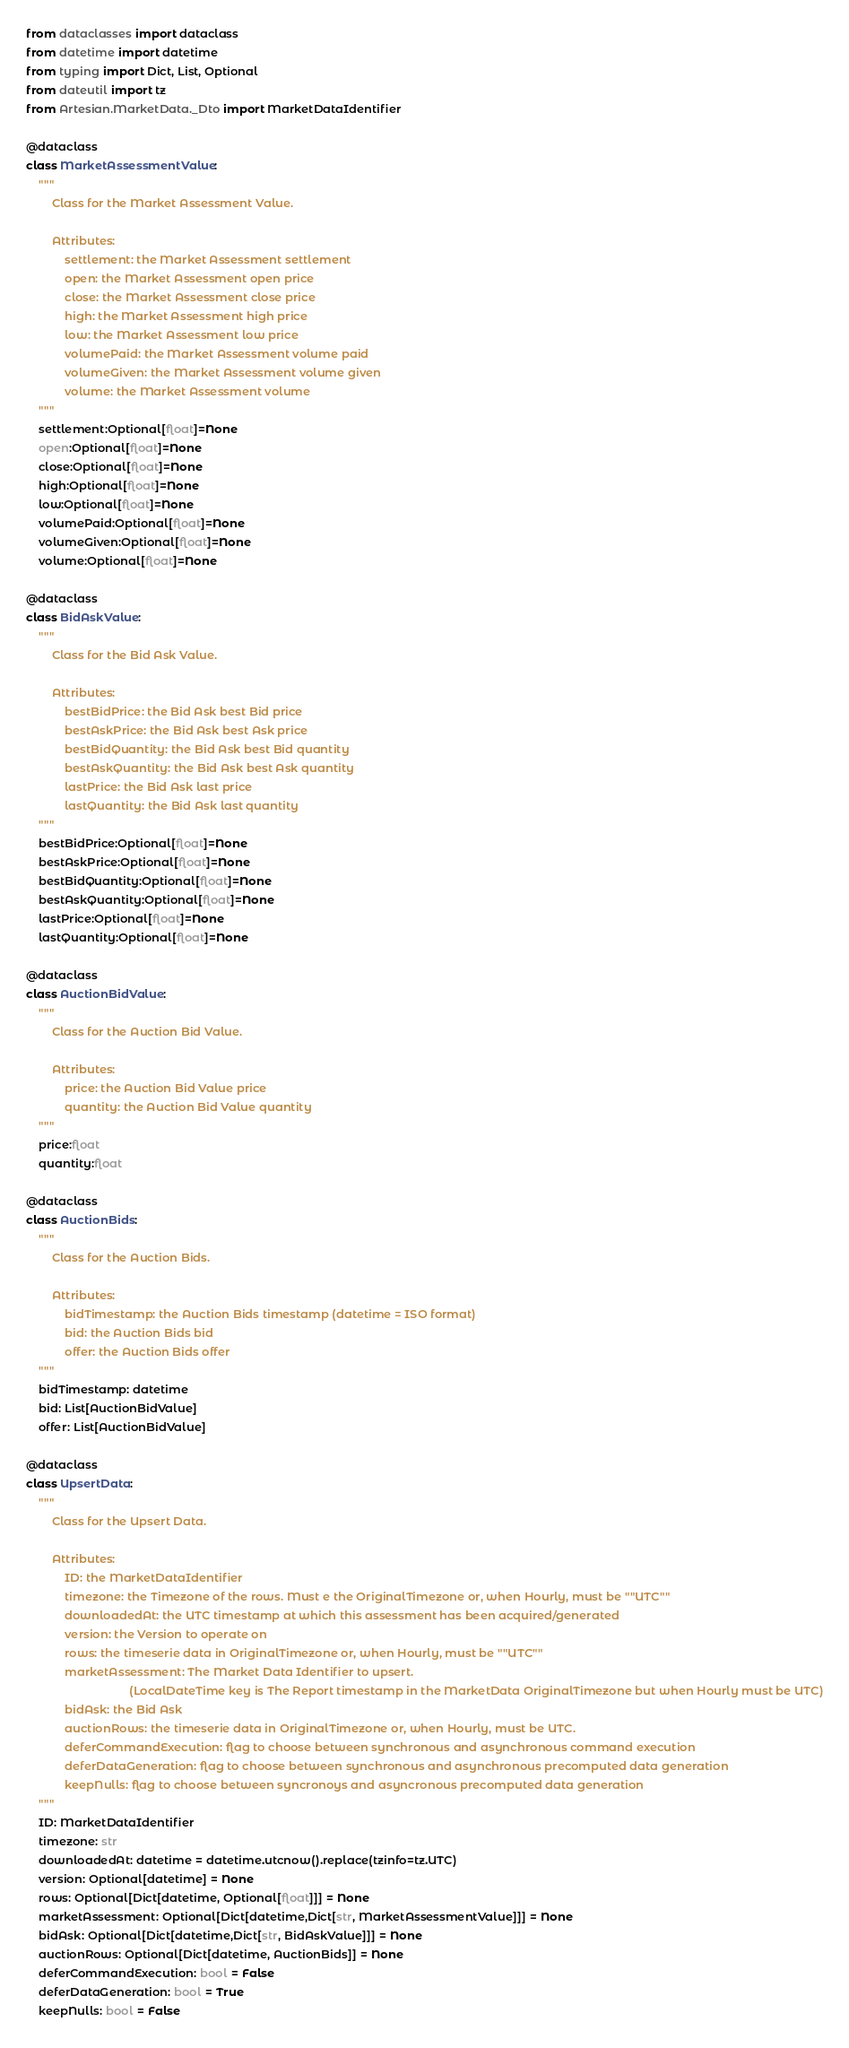<code> <loc_0><loc_0><loc_500><loc_500><_Python_>from dataclasses import dataclass
from datetime import datetime
from typing import Dict, List, Optional
from dateutil import tz
from Artesian.MarketData._Dto import MarketDataIdentifier

@dataclass
class MarketAssessmentValue:
    """
        Class for the Market Assessment Value.

        Attributes:
            settlement: the Market Assessment settlement
            open: the Market Assessment open price
            close: the Market Assessment close price
            high: the Market Assessment high price
            low: the Market Assessment low price
            volumePaid: the Market Assessment volume paid
            volumeGiven: the Market Assessment volume given
            volume: the Market Assessment volume
    """
    settlement:Optional[float]=None
    open:Optional[float]=None
    close:Optional[float]=None
    high:Optional[float]=None
    low:Optional[float]=None
    volumePaid:Optional[float]=None
    volumeGiven:Optional[float]=None
    volume:Optional[float]=None

@dataclass
class BidAskValue:
    """
        Class for the Bid Ask Value.

        Attributes:
            bestBidPrice: the Bid Ask best Bid price
            bestAskPrice: the Bid Ask best Ask price
            bestBidQuantity: the Bid Ask best Bid quantity
            bestAskQuantity: the Bid Ask best Ask quantity
            lastPrice: the Bid Ask last price
            lastQuantity: the Bid Ask last quantity
    """
    bestBidPrice:Optional[float]=None
    bestAskPrice:Optional[float]=None
    bestBidQuantity:Optional[float]=None
    bestAskQuantity:Optional[float]=None
    lastPrice:Optional[float]=None
    lastQuantity:Optional[float]=None

@dataclass
class AuctionBidValue:
    """
        Class for the Auction Bid Value.

        Attributes:
            price: the Auction Bid Value price
            quantity: the Auction Bid Value quantity
    """
    price:float
    quantity:float

@dataclass
class AuctionBids:
    """
        Class for the Auction Bids.

        Attributes:
            bidTimestamp: the Auction Bids timestamp (datetime = ISO format)
            bid: the Auction Bids bid 
            offer: the Auction Bids offer
    """
    bidTimestamp: datetime
    bid: List[AuctionBidValue]
    offer: List[AuctionBidValue]

@dataclass
class UpsertData:
    """
        Class for the Upsert Data.

        Attributes:
            ID: the MarketDataIdentifier
            timezone: the Timezone of the rows. Must e the OriginalTimezone or, when Hourly, must be ""UTC""
            downloadedAt: the UTC timestamp at which this assessment has been acquired/generated
            version: the Version to operate on
            rows: the timeserie data in OriginalTimezone or, when Hourly, must be ""UTC""
            marketAssessment: The Market Data Identifier to upsert. 
                                (LocalDateTime key is The Report timestamp in the MarketData OriginalTimezone but when Hourly must be UTC)
            bidAsk: the Bid Ask
            auctionRows: the timeserie data in OriginalTimezone or, when Hourly, must be UTC.
            deferCommandExecution: flag to choose between synchronous and asynchronous command execution
            deferDataGeneration: flag to choose between synchronous and asynchronous precomputed data generation
            keepNulls: flag to choose between syncronoys and asyncronous precomputed data generation
    """
    ID: MarketDataIdentifier
    timezone: str
    downloadedAt: datetime = datetime.utcnow().replace(tzinfo=tz.UTC)
    version: Optional[datetime] = None
    rows: Optional[Dict[datetime, Optional[float]]] = None
    marketAssessment: Optional[Dict[datetime,Dict[str, MarketAssessmentValue]]] = None
    bidAsk: Optional[Dict[datetime,Dict[str, BidAskValue]]] = None
    auctionRows: Optional[Dict[datetime, AuctionBids]] = None
    deferCommandExecution: bool = False
    deferDataGeneration: bool = True
    keepNulls: bool = False
</code> 